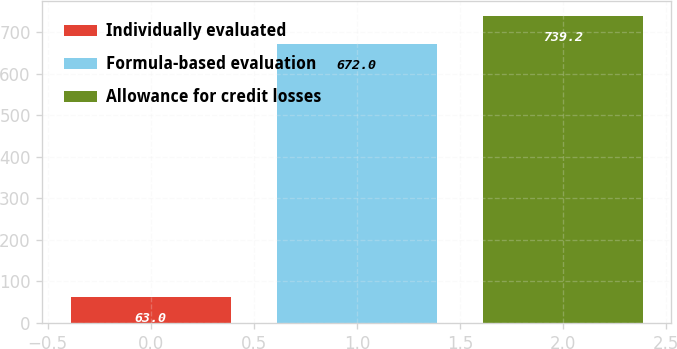Convert chart. <chart><loc_0><loc_0><loc_500><loc_500><bar_chart><fcel>Individually evaluated<fcel>Formula-based evaluation<fcel>Allowance for credit losses<nl><fcel>63<fcel>672<fcel>739.2<nl></chart> 